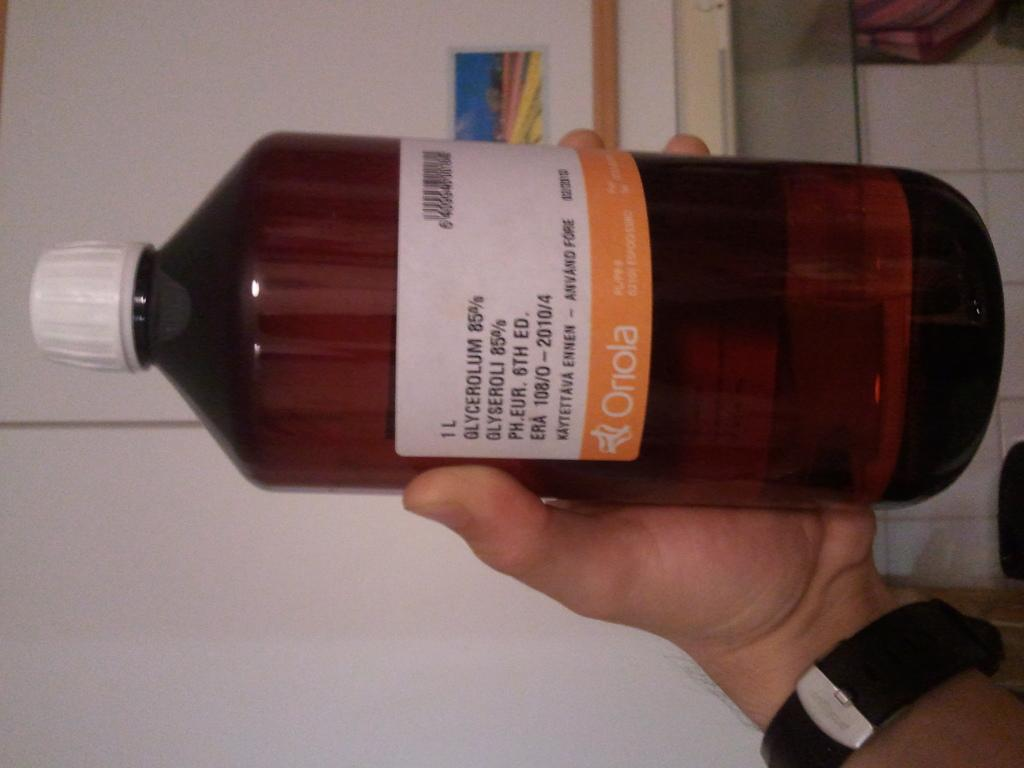What object is being held in the image? There is a bottle in the image, and it is being held by a hand. What type of yak can be seen in the image? There is no yak present in the image; it only features a bottle being held by a hand. 